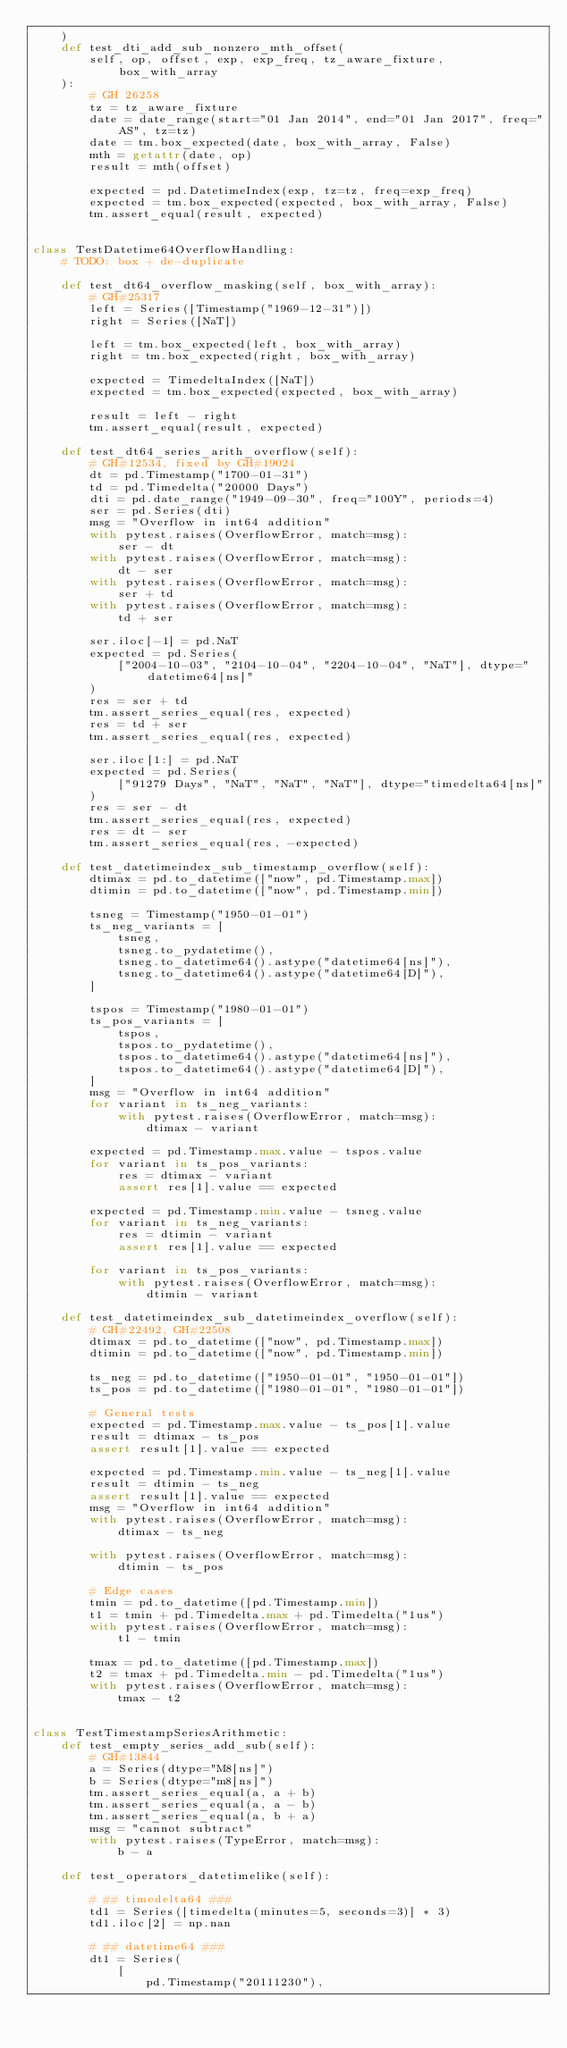<code> <loc_0><loc_0><loc_500><loc_500><_Python_>    )
    def test_dti_add_sub_nonzero_mth_offset(
        self, op, offset, exp, exp_freq, tz_aware_fixture, box_with_array
    ):
        # GH 26258
        tz = tz_aware_fixture
        date = date_range(start="01 Jan 2014", end="01 Jan 2017", freq="AS", tz=tz)
        date = tm.box_expected(date, box_with_array, False)
        mth = getattr(date, op)
        result = mth(offset)

        expected = pd.DatetimeIndex(exp, tz=tz, freq=exp_freq)
        expected = tm.box_expected(expected, box_with_array, False)
        tm.assert_equal(result, expected)


class TestDatetime64OverflowHandling:
    # TODO: box + de-duplicate

    def test_dt64_overflow_masking(self, box_with_array):
        # GH#25317
        left = Series([Timestamp("1969-12-31")])
        right = Series([NaT])

        left = tm.box_expected(left, box_with_array)
        right = tm.box_expected(right, box_with_array)

        expected = TimedeltaIndex([NaT])
        expected = tm.box_expected(expected, box_with_array)

        result = left - right
        tm.assert_equal(result, expected)

    def test_dt64_series_arith_overflow(self):
        # GH#12534, fixed by GH#19024
        dt = pd.Timestamp("1700-01-31")
        td = pd.Timedelta("20000 Days")
        dti = pd.date_range("1949-09-30", freq="100Y", periods=4)
        ser = pd.Series(dti)
        msg = "Overflow in int64 addition"
        with pytest.raises(OverflowError, match=msg):
            ser - dt
        with pytest.raises(OverflowError, match=msg):
            dt - ser
        with pytest.raises(OverflowError, match=msg):
            ser + td
        with pytest.raises(OverflowError, match=msg):
            td + ser

        ser.iloc[-1] = pd.NaT
        expected = pd.Series(
            ["2004-10-03", "2104-10-04", "2204-10-04", "NaT"], dtype="datetime64[ns]"
        )
        res = ser + td
        tm.assert_series_equal(res, expected)
        res = td + ser
        tm.assert_series_equal(res, expected)

        ser.iloc[1:] = pd.NaT
        expected = pd.Series(
            ["91279 Days", "NaT", "NaT", "NaT"], dtype="timedelta64[ns]"
        )
        res = ser - dt
        tm.assert_series_equal(res, expected)
        res = dt - ser
        tm.assert_series_equal(res, -expected)

    def test_datetimeindex_sub_timestamp_overflow(self):
        dtimax = pd.to_datetime(["now", pd.Timestamp.max])
        dtimin = pd.to_datetime(["now", pd.Timestamp.min])

        tsneg = Timestamp("1950-01-01")
        ts_neg_variants = [
            tsneg,
            tsneg.to_pydatetime(),
            tsneg.to_datetime64().astype("datetime64[ns]"),
            tsneg.to_datetime64().astype("datetime64[D]"),
        ]

        tspos = Timestamp("1980-01-01")
        ts_pos_variants = [
            tspos,
            tspos.to_pydatetime(),
            tspos.to_datetime64().astype("datetime64[ns]"),
            tspos.to_datetime64().astype("datetime64[D]"),
        ]
        msg = "Overflow in int64 addition"
        for variant in ts_neg_variants:
            with pytest.raises(OverflowError, match=msg):
                dtimax - variant

        expected = pd.Timestamp.max.value - tspos.value
        for variant in ts_pos_variants:
            res = dtimax - variant
            assert res[1].value == expected

        expected = pd.Timestamp.min.value - tsneg.value
        for variant in ts_neg_variants:
            res = dtimin - variant
            assert res[1].value == expected

        for variant in ts_pos_variants:
            with pytest.raises(OverflowError, match=msg):
                dtimin - variant

    def test_datetimeindex_sub_datetimeindex_overflow(self):
        # GH#22492, GH#22508
        dtimax = pd.to_datetime(["now", pd.Timestamp.max])
        dtimin = pd.to_datetime(["now", pd.Timestamp.min])

        ts_neg = pd.to_datetime(["1950-01-01", "1950-01-01"])
        ts_pos = pd.to_datetime(["1980-01-01", "1980-01-01"])

        # General tests
        expected = pd.Timestamp.max.value - ts_pos[1].value
        result = dtimax - ts_pos
        assert result[1].value == expected

        expected = pd.Timestamp.min.value - ts_neg[1].value
        result = dtimin - ts_neg
        assert result[1].value == expected
        msg = "Overflow in int64 addition"
        with pytest.raises(OverflowError, match=msg):
            dtimax - ts_neg

        with pytest.raises(OverflowError, match=msg):
            dtimin - ts_pos

        # Edge cases
        tmin = pd.to_datetime([pd.Timestamp.min])
        t1 = tmin + pd.Timedelta.max + pd.Timedelta("1us")
        with pytest.raises(OverflowError, match=msg):
            t1 - tmin

        tmax = pd.to_datetime([pd.Timestamp.max])
        t2 = tmax + pd.Timedelta.min - pd.Timedelta("1us")
        with pytest.raises(OverflowError, match=msg):
            tmax - t2


class TestTimestampSeriesArithmetic:
    def test_empty_series_add_sub(self):
        # GH#13844
        a = Series(dtype="M8[ns]")
        b = Series(dtype="m8[ns]")
        tm.assert_series_equal(a, a + b)
        tm.assert_series_equal(a, a - b)
        tm.assert_series_equal(a, b + a)
        msg = "cannot subtract"
        with pytest.raises(TypeError, match=msg):
            b - a

    def test_operators_datetimelike(self):

        # ## timedelta64 ###
        td1 = Series([timedelta(minutes=5, seconds=3)] * 3)
        td1.iloc[2] = np.nan

        # ## datetime64 ###
        dt1 = Series(
            [
                pd.Timestamp("20111230"),</code> 